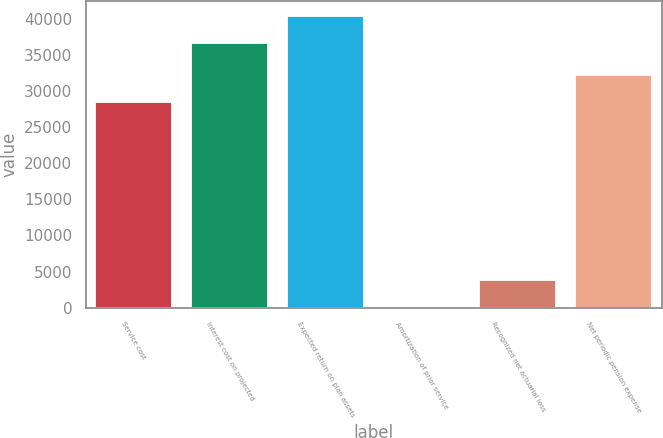Convert chart. <chart><loc_0><loc_0><loc_500><loc_500><bar_chart><fcel>Service cost<fcel>Interest cost on projected<fcel>Expected return on plan assets<fcel>Amortization of prior service<fcel>Recognized net actuarial loss<fcel>Net periodic pension expense<nl><fcel>28505<fcel>36704<fcel>40462.5<fcel>57<fcel>3815.5<fcel>32263.5<nl></chart> 